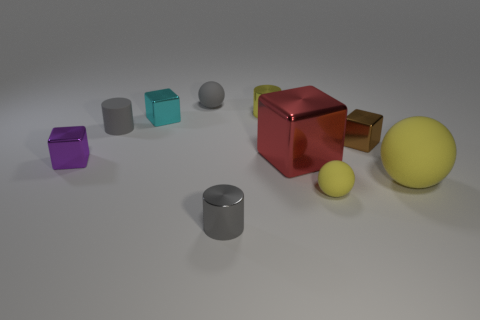Subtract all gray cylinders. How many cylinders are left? 1 Subtract all balls. How many objects are left? 7 Subtract 3 balls. How many balls are left? 0 Add 3 gray spheres. How many gray spheres are left? 4 Add 3 tiny yellow metal cubes. How many tiny yellow metal cubes exist? 3 Subtract all brown cubes. How many cubes are left? 3 Subtract 0 yellow cubes. How many objects are left? 10 Subtract all cyan spheres. Subtract all red cubes. How many spheres are left? 3 Subtract all brown cylinders. How many gray blocks are left? 0 Subtract all large green shiny cylinders. Subtract all big red metal things. How many objects are left? 9 